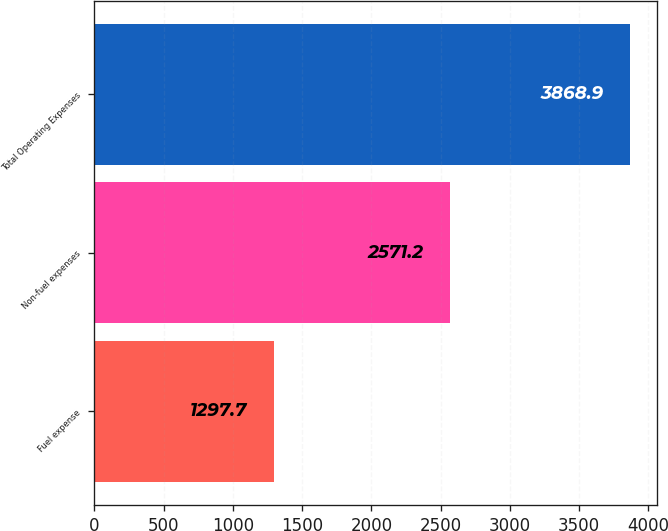<chart> <loc_0><loc_0><loc_500><loc_500><bar_chart><fcel>Fuel expense<fcel>Non-fuel expenses<fcel>Total Operating Expenses<nl><fcel>1297.7<fcel>2571.2<fcel>3868.9<nl></chart> 